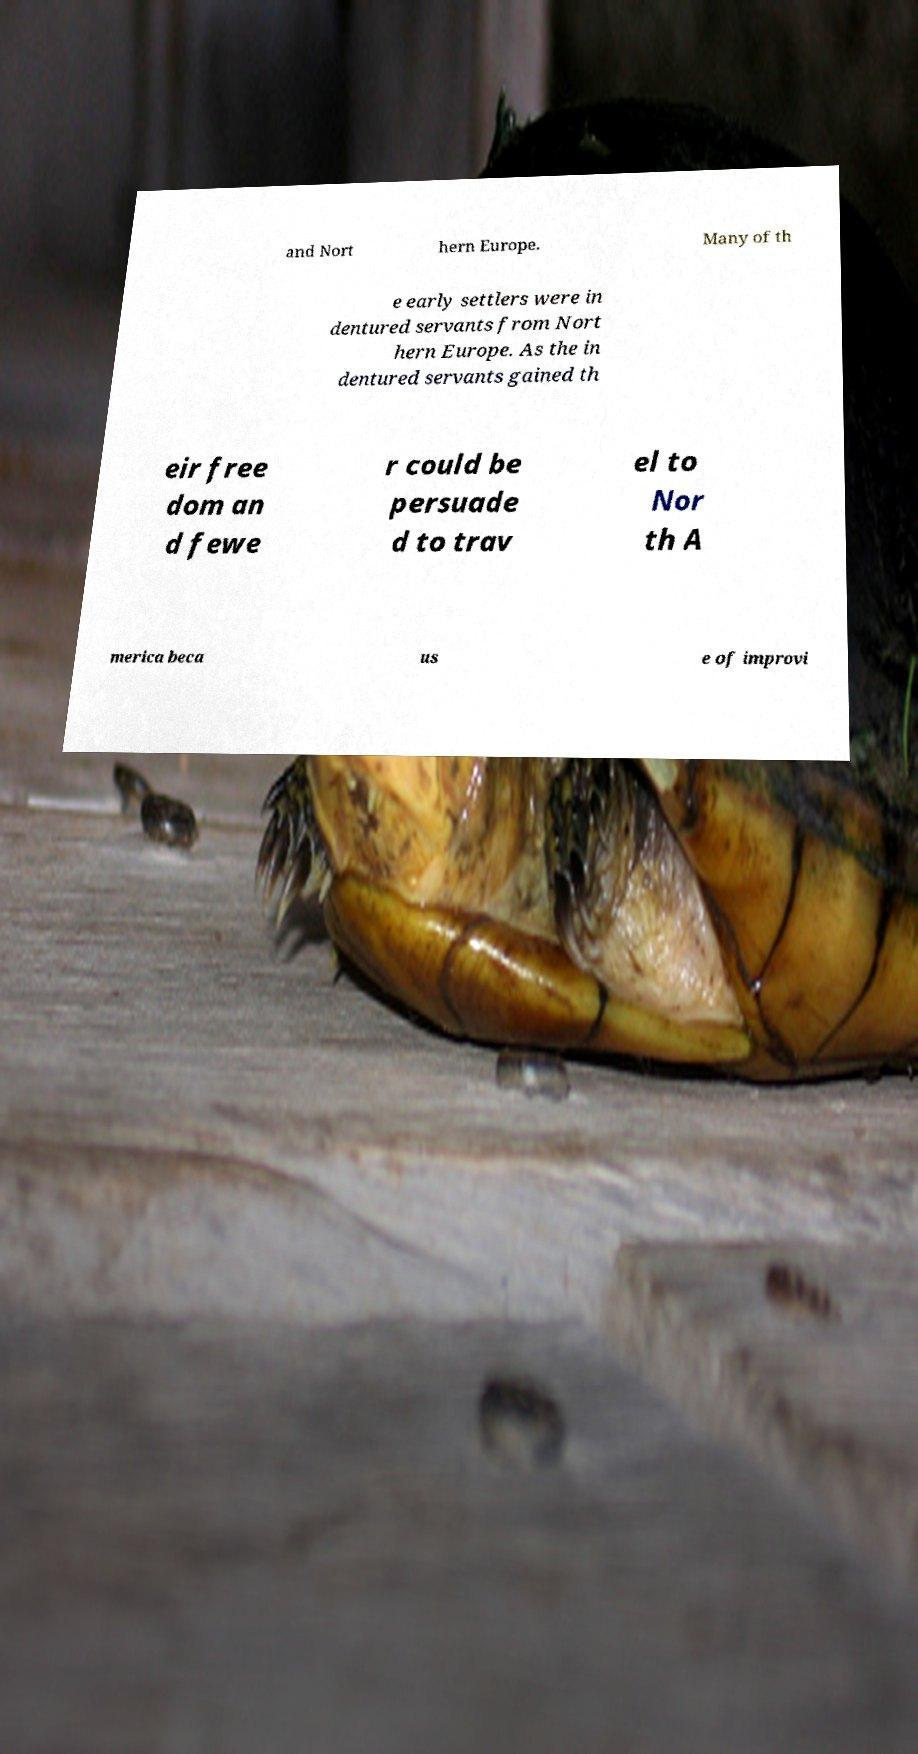I need the written content from this picture converted into text. Can you do that? and Nort hern Europe. Many of th e early settlers were in dentured servants from Nort hern Europe. As the in dentured servants gained th eir free dom an d fewe r could be persuade d to trav el to Nor th A merica beca us e of improvi 